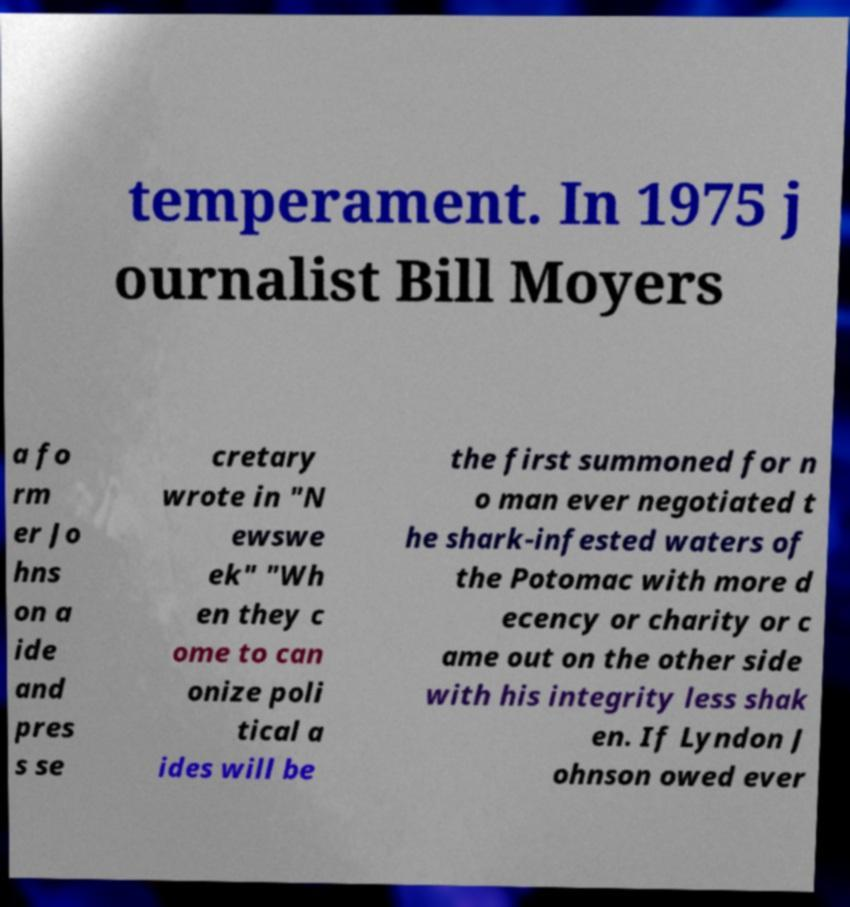Please identify and transcribe the text found in this image. temperament. In 1975 j ournalist Bill Moyers a fo rm er Jo hns on a ide and pres s se cretary wrote in "N ewswe ek" "Wh en they c ome to can onize poli tical a ides will be the first summoned for n o man ever negotiated t he shark-infested waters of the Potomac with more d ecency or charity or c ame out on the other side with his integrity less shak en. If Lyndon J ohnson owed ever 